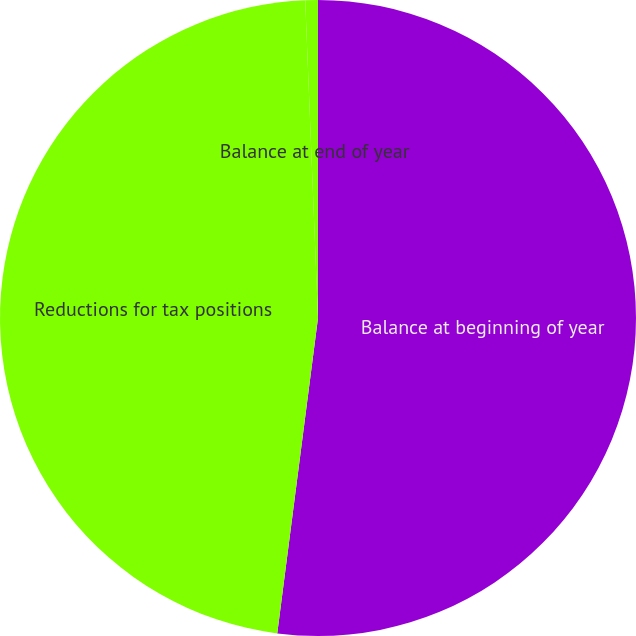Convert chart to OTSL. <chart><loc_0><loc_0><loc_500><loc_500><pie_chart><fcel>Balance at beginning of year<fcel>Reductions for tax positions<fcel>Balance at end of year<nl><fcel>52.04%<fcel>47.31%<fcel>0.64%<nl></chart> 